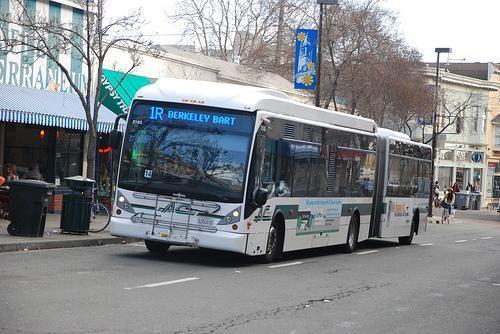How many buses are there?
Give a very brief answer. 1. 